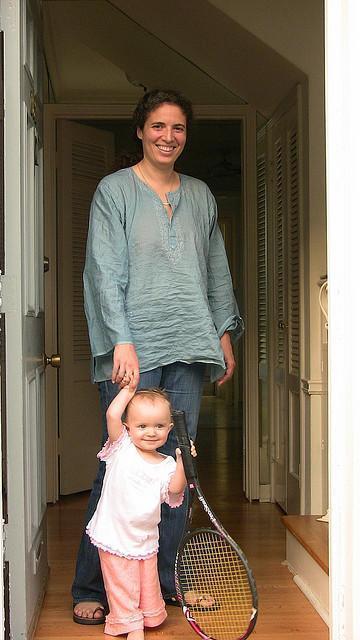How many babies are in the house?
Give a very brief answer. 1. How many people are in the photo?
Give a very brief answer. 2. 